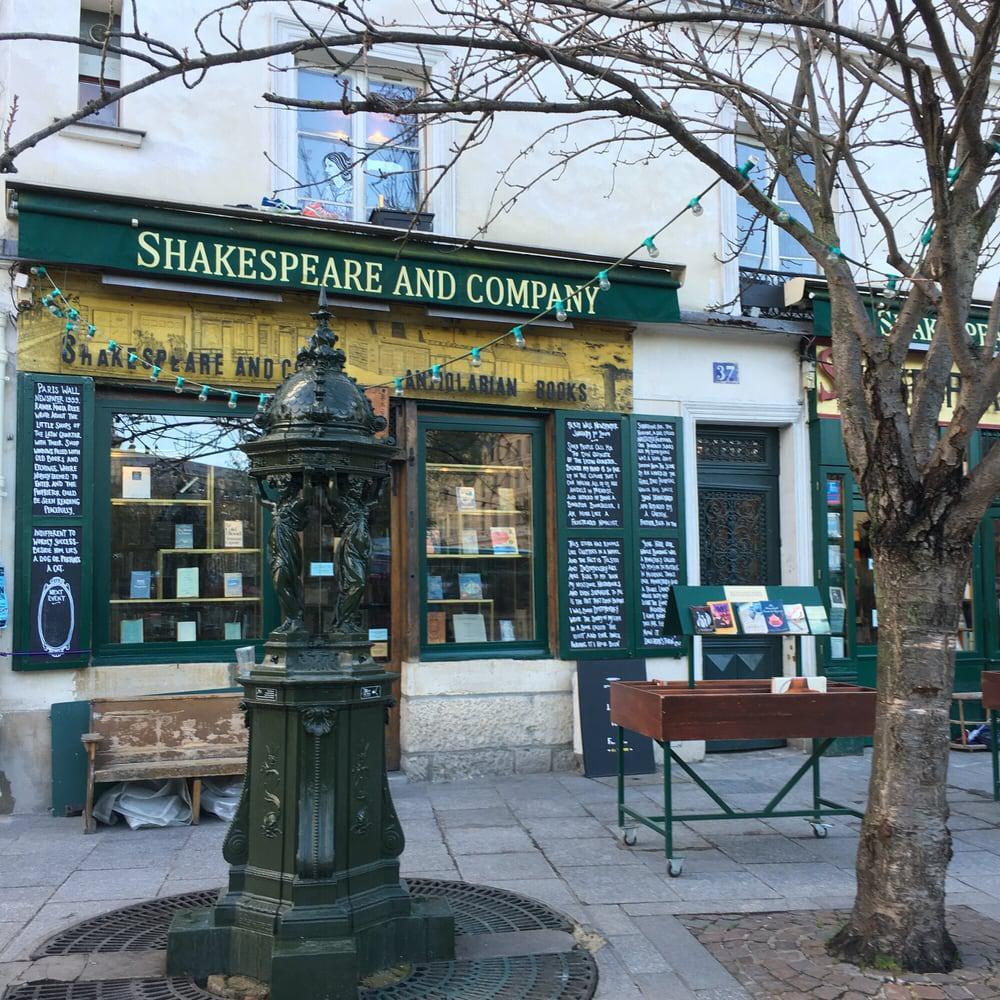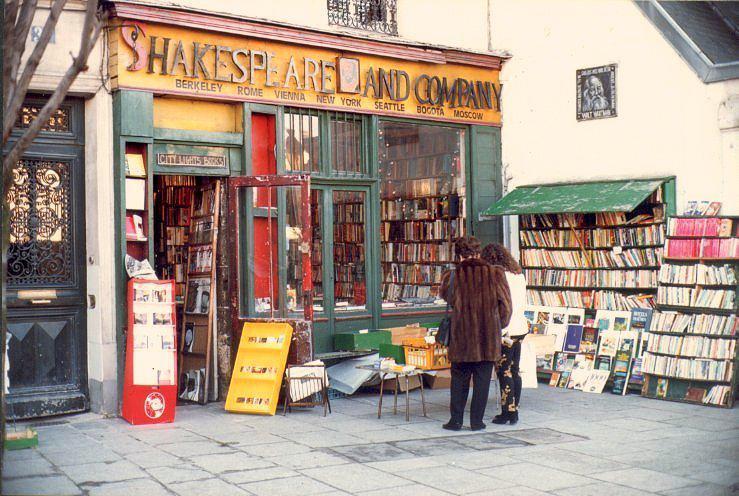The first image is the image on the left, the second image is the image on the right. Given the left and right images, does the statement "There are more than two people at the bookstore in one of the images." hold true? Answer yes or no. No. 